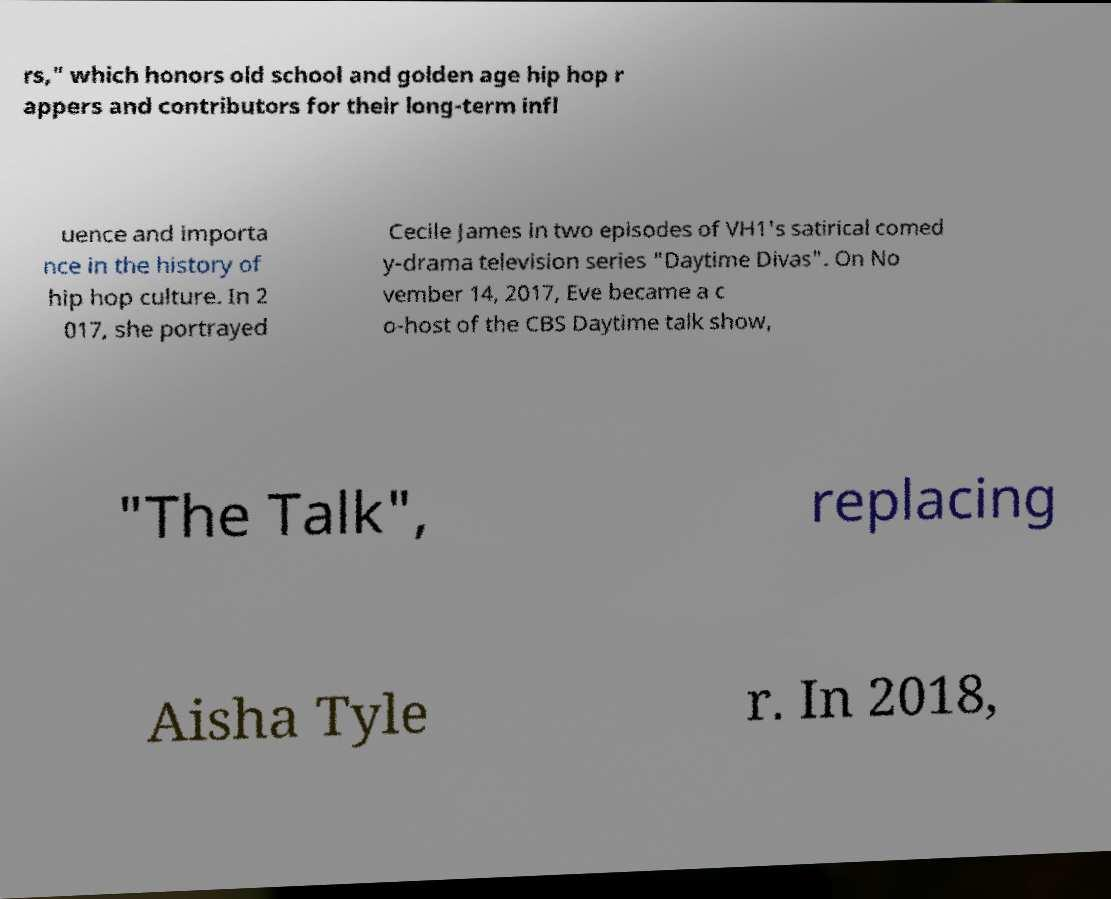I need the written content from this picture converted into text. Can you do that? rs," which honors old school and golden age hip hop r appers and contributors for their long-term infl uence and importa nce in the history of hip hop culture. In 2 017, she portrayed Cecile James in two episodes of VH1's satirical comed y-drama television series "Daytime Divas". On No vember 14, 2017, Eve became a c o-host of the CBS Daytime talk show, "The Talk", replacing Aisha Tyle r. In 2018, 